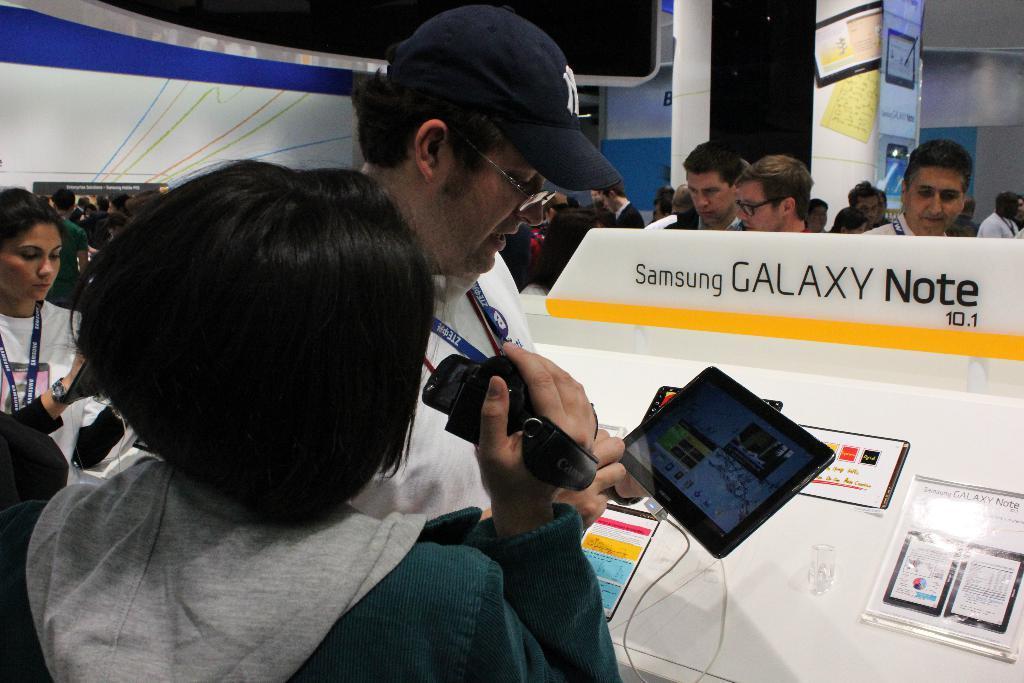In one or two sentences, can you explain what this image depicts? In this image we can see people standing on the floor and some of them are holding cameras and tablets in their hands. 